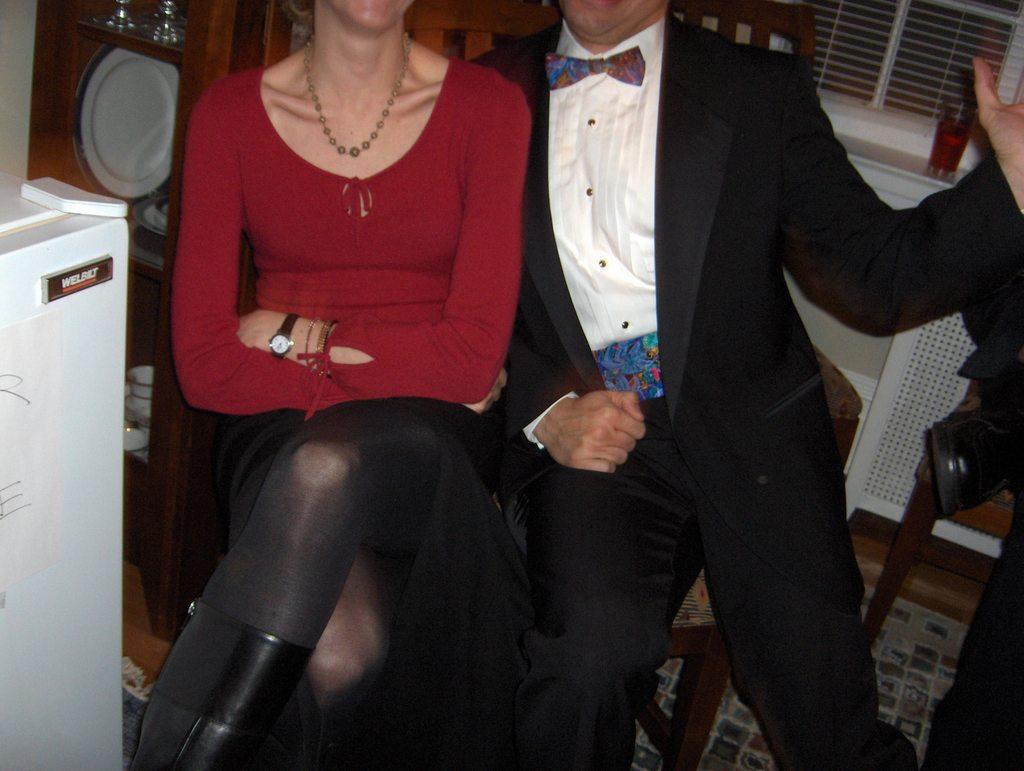Can you describe this image briefly? In this image I can see two people sitting on the chair. At the right I can see plates,cup and some of the objects inside the cupboard. In the back there is a window. In front of window there is a glass with drink. 